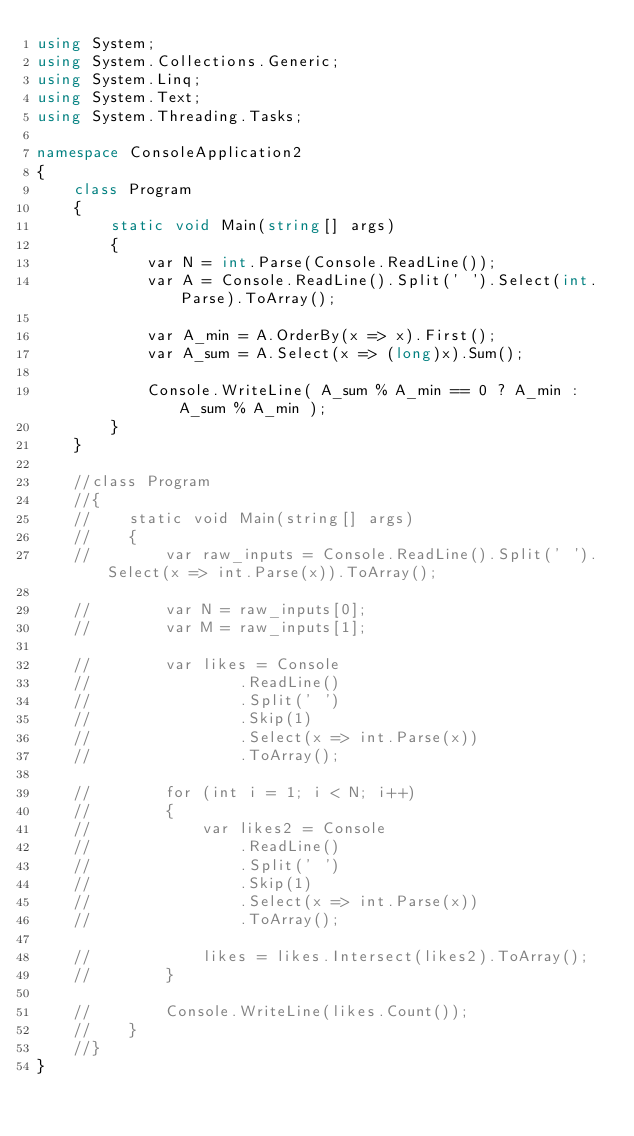Convert code to text. <code><loc_0><loc_0><loc_500><loc_500><_C#_>using System;
using System.Collections.Generic;
using System.Linq;
using System.Text;
using System.Threading.Tasks;

namespace ConsoleApplication2
{
    class Program
    {
        static void Main(string[] args)
        {
            var N = int.Parse(Console.ReadLine());
            var A = Console.ReadLine().Split(' ').Select(int.Parse).ToArray();

            var A_min = A.OrderBy(x => x).First();
            var A_sum = A.Select(x => (long)x).Sum();

            Console.WriteLine( A_sum % A_min == 0 ? A_min : A_sum % A_min );
        }
    }

    //class Program
    //{
    //    static void Main(string[] args)
    //    {
    //        var raw_inputs = Console.ReadLine().Split(' ').Select(x => int.Parse(x)).ToArray();

    //        var N = raw_inputs[0];
    //        var M = raw_inputs[1];

    //        var likes = Console
    //                .ReadLine()
    //                .Split(' ')
    //                .Skip(1)
    //                .Select(x => int.Parse(x))
    //                .ToArray();

    //        for (int i = 1; i < N; i++)
    //        {
    //            var likes2 = Console
    //                .ReadLine()
    //                .Split(' ')
    //                .Skip(1)
    //                .Select(x => int.Parse(x))
    //                .ToArray();

    //            likes = likes.Intersect(likes2).ToArray();
    //        }

    //        Console.WriteLine(likes.Count());
    //    }
    //}
}
</code> 